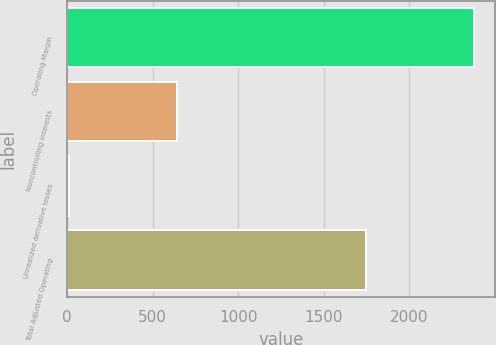Convert chart to OTSL. <chart><loc_0><loc_0><loc_500><loc_500><bar_chart><fcel>Operating Margin<fcel>Noncontrolling interests<fcel>Unrealized derivative losses<fcel>Total Adjusted Operating<nl><fcel>2380<fcel>644<fcel>9<fcel>1745<nl></chart> 